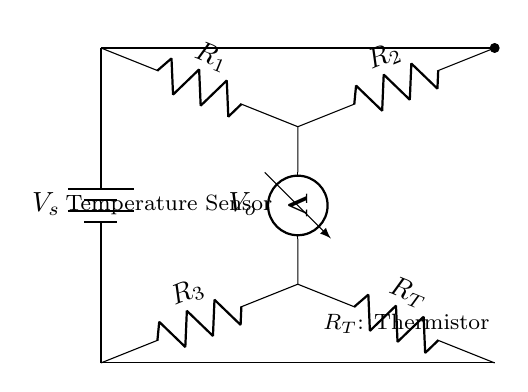What is the function of the thermistor labeled \( R_T \)? The thermistor is a type of temperature sensor that changes its resistance with temperature variations, making it essential for measuring temperature in the circuit.
Answer: Temperature Sensor What are the resistance values represented in the circuit? The circuit shows three resistors: \( R_1 \), \( R_2 \), and \( R_3 \). Additionally, it includes a thermistor labeled \( R_T \). The values denote their roles as components in the temperature sensing circuit.
Answer: \( R_1, R_2, R_3, R_T \) What is the purpose of the voltmeter in the circuit? The voltmeter measures the voltage across two points in the circuit (between the midpoints of \( R_1 \) and \( R_3 \)), indicating how much voltage drop occurs due to the thermistor \( R_T \) and helping in determining the temperature.
Answer: Measure voltage \( V_o \) How does the circuit indicate temperature change? The circuit's output voltage \( V_o \) varies with changes in the resistance of the thermistor \( R_T \), which is influenced by temperature. An increase in temperature decreases the resistance of the thermistor, affecting the voltage \( V_o \).
Answer: Output voltage \( V_o \) What type of circuit is represented here? This is a resistance-based temperature sensing bridge circuit, specifically a Wheatstone bridge configuration, used to balance the circuit for temperature measurement.
Answer: Bridge circuit What is the voltage provided by the battery in this circuit? The battery provides a constant voltage supply \( V_s \) across the circuit, serving as the power source for measuring resistances and the resultant voltage outputs.
Answer: \( V_s \) 